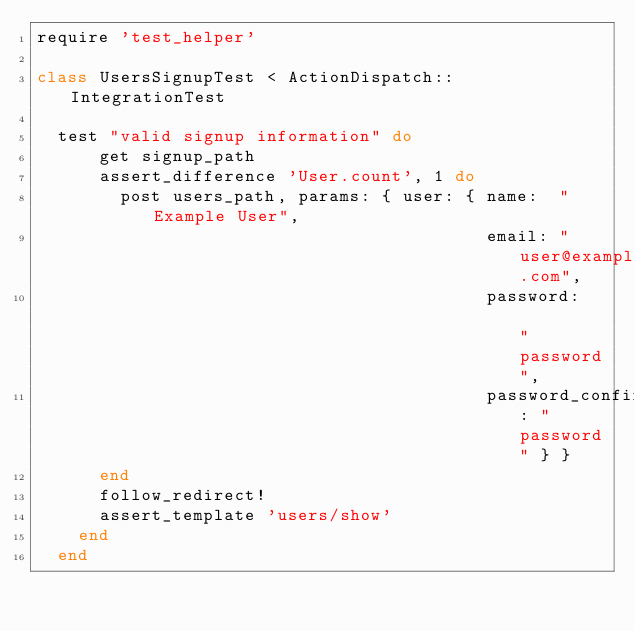<code> <loc_0><loc_0><loc_500><loc_500><_Ruby_>require 'test_helper'

class UsersSignupTest < ActionDispatch::IntegrationTest

  test "valid signup information" do
      get signup_path
      assert_difference 'User.count', 1 do
        post users_path, params: { user: { name:  "Example User",
                                           email: "user@example.com",
                                           password:              "password",
                                           password_confirmation: "password" } }
      end
      follow_redirect!
      assert_template 'users/show'
    end
  end
</code> 